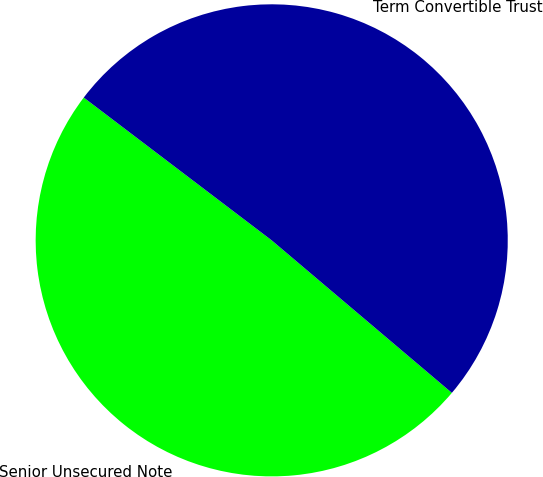Convert chart to OTSL. <chart><loc_0><loc_0><loc_500><loc_500><pie_chart><fcel>Senior Unsecured Note<fcel>Term Convertible Trust<nl><fcel>49.16%<fcel>50.84%<nl></chart> 